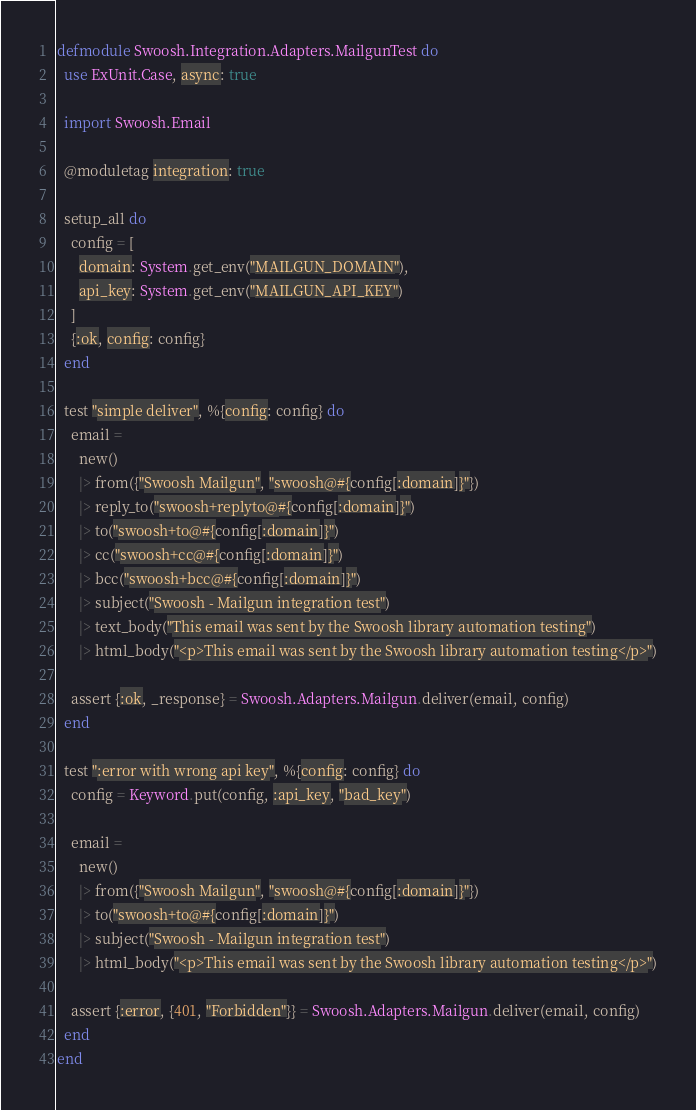Convert code to text. <code><loc_0><loc_0><loc_500><loc_500><_Elixir_>defmodule Swoosh.Integration.Adapters.MailgunTest do
  use ExUnit.Case, async: true

  import Swoosh.Email

  @moduletag integration: true

  setup_all do
    config = [
      domain: System.get_env("MAILGUN_DOMAIN"),
      api_key: System.get_env("MAILGUN_API_KEY")
    ]
    {:ok, config: config}
  end

  test "simple deliver", %{config: config} do
    email =
      new()
      |> from({"Swoosh Mailgun", "swoosh@#{config[:domain]}"})
      |> reply_to("swoosh+replyto@#{config[:domain]}")
      |> to("swoosh+to@#{config[:domain]}")
      |> cc("swoosh+cc@#{config[:domain]}")
      |> bcc("swoosh+bcc@#{config[:domain]}")
      |> subject("Swoosh - Mailgun integration test")
      |> text_body("This email was sent by the Swoosh library automation testing")
      |> html_body("<p>This email was sent by the Swoosh library automation testing</p>")

    assert {:ok, _response} = Swoosh.Adapters.Mailgun.deliver(email, config)
  end

  test ":error with wrong api key", %{config: config} do
    config = Keyword.put(config, :api_key, "bad_key")

    email =
      new()
      |> from({"Swoosh Mailgun", "swoosh@#{config[:domain]}"})
      |> to("swoosh+to@#{config[:domain]}")
      |> subject("Swoosh - Mailgun integration test")
      |> html_body("<p>This email was sent by the Swoosh library automation testing</p>")

    assert {:error, {401, "Forbidden"}} = Swoosh.Adapters.Mailgun.deliver(email, config)
  end
end
</code> 